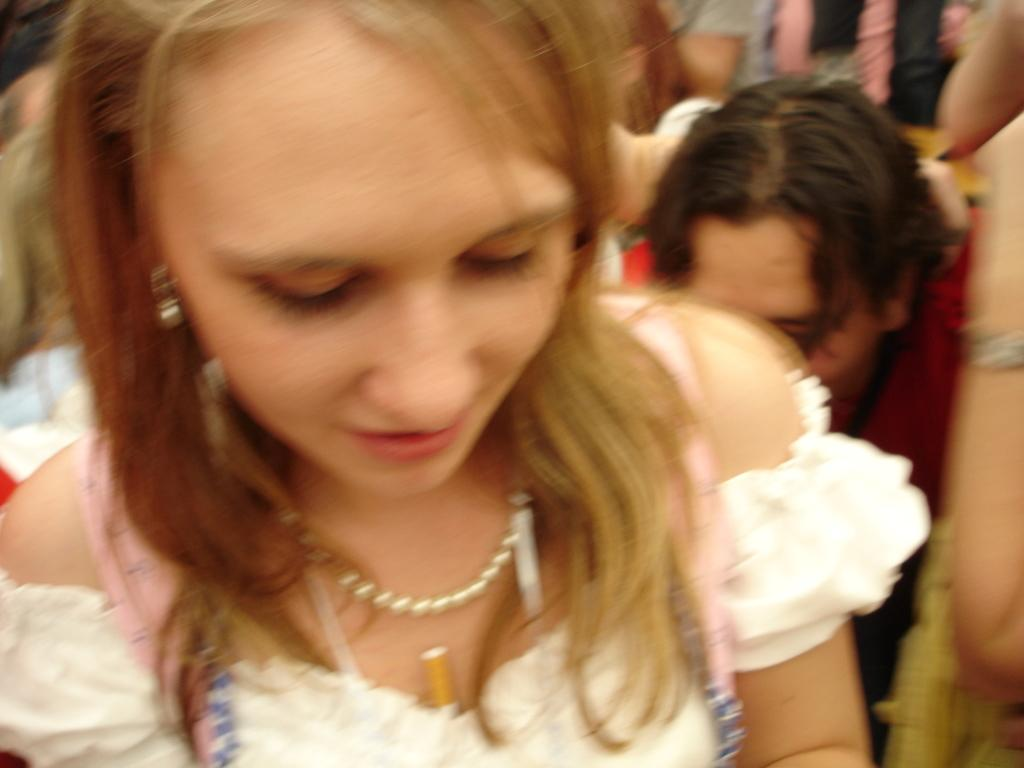What is the woman in the image wearing? The woman in the image is wearing a white dress. Where is the man located in the image? The man is on the left side of the image. Can you describe the background of the image? The background has a blurred view, and there are people visible in it. What type of comfort can be seen in the image? There is no specific type of comfort visible in the image. What kind of wine is being served in the image? There is no wine present in the image. 